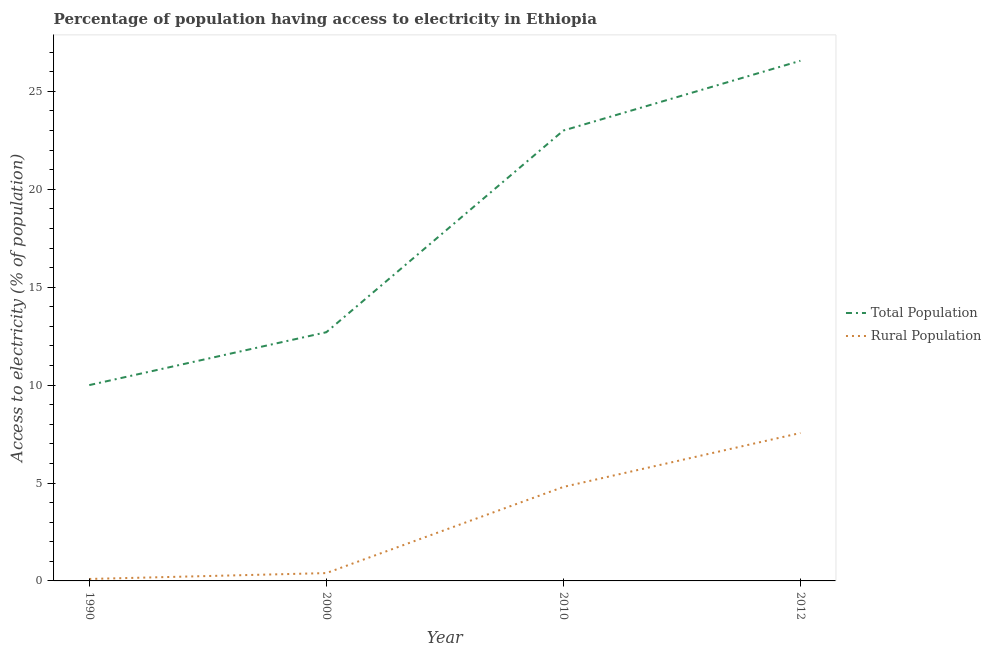Is the number of lines equal to the number of legend labels?
Ensure brevity in your answer.  Yes. Across all years, what is the maximum percentage of rural population having access to electricity?
Offer a very short reply. 7.55. What is the total percentage of population having access to electricity in the graph?
Your answer should be compact. 72.26. What is the difference between the percentage of rural population having access to electricity in 1990 and that in 2000?
Your response must be concise. -0.3. What is the difference between the percentage of population having access to electricity in 1990 and the percentage of rural population having access to electricity in 2012?
Keep it short and to the point. 2.45. What is the average percentage of rural population having access to electricity per year?
Your answer should be very brief. 3.21. In the year 2000, what is the difference between the percentage of rural population having access to electricity and percentage of population having access to electricity?
Your response must be concise. -12.3. What is the ratio of the percentage of population having access to electricity in 2000 to that in 2012?
Your answer should be compact. 0.48. What is the difference between the highest and the second highest percentage of population having access to electricity?
Ensure brevity in your answer.  3.56. What is the difference between the highest and the lowest percentage of population having access to electricity?
Keep it short and to the point. 16.56. Is the percentage of rural population having access to electricity strictly less than the percentage of population having access to electricity over the years?
Keep it short and to the point. Yes. How many lines are there?
Ensure brevity in your answer.  2. What is the difference between two consecutive major ticks on the Y-axis?
Your answer should be very brief. 5. Are the values on the major ticks of Y-axis written in scientific E-notation?
Make the answer very short. No. Does the graph contain grids?
Your answer should be very brief. No. What is the title of the graph?
Your answer should be compact. Percentage of population having access to electricity in Ethiopia. What is the label or title of the Y-axis?
Provide a short and direct response. Access to electricity (% of population). What is the Access to electricity (% of population) in Rural Population in 2000?
Ensure brevity in your answer.  0.4. What is the Access to electricity (% of population) of Total Population in 2010?
Provide a succinct answer. 23. What is the Access to electricity (% of population) of Total Population in 2012?
Your answer should be compact. 26.56. What is the Access to electricity (% of population) of Rural Population in 2012?
Give a very brief answer. 7.55. Across all years, what is the maximum Access to electricity (% of population) of Total Population?
Your answer should be very brief. 26.56. Across all years, what is the maximum Access to electricity (% of population) of Rural Population?
Your answer should be compact. 7.55. What is the total Access to electricity (% of population) in Total Population in the graph?
Make the answer very short. 72.26. What is the total Access to electricity (% of population) of Rural Population in the graph?
Provide a short and direct response. 12.85. What is the difference between the Access to electricity (% of population) in Total Population in 1990 and that in 2000?
Keep it short and to the point. -2.7. What is the difference between the Access to electricity (% of population) in Rural Population in 1990 and that in 2000?
Your answer should be very brief. -0.3. What is the difference between the Access to electricity (% of population) in Total Population in 1990 and that in 2010?
Keep it short and to the point. -13. What is the difference between the Access to electricity (% of population) in Total Population in 1990 and that in 2012?
Offer a terse response. -16.56. What is the difference between the Access to electricity (% of population) in Rural Population in 1990 and that in 2012?
Offer a terse response. -7.45. What is the difference between the Access to electricity (% of population) in Total Population in 2000 and that in 2010?
Provide a succinct answer. -10.3. What is the difference between the Access to electricity (% of population) in Rural Population in 2000 and that in 2010?
Provide a succinct answer. -4.4. What is the difference between the Access to electricity (% of population) of Total Population in 2000 and that in 2012?
Give a very brief answer. -13.86. What is the difference between the Access to electricity (% of population) of Rural Population in 2000 and that in 2012?
Give a very brief answer. -7.15. What is the difference between the Access to electricity (% of population) of Total Population in 2010 and that in 2012?
Keep it short and to the point. -3.56. What is the difference between the Access to electricity (% of population) in Rural Population in 2010 and that in 2012?
Offer a very short reply. -2.75. What is the difference between the Access to electricity (% of population) of Total Population in 1990 and the Access to electricity (% of population) of Rural Population in 2010?
Provide a short and direct response. 5.2. What is the difference between the Access to electricity (% of population) of Total Population in 1990 and the Access to electricity (% of population) of Rural Population in 2012?
Your answer should be compact. 2.45. What is the difference between the Access to electricity (% of population) in Total Population in 2000 and the Access to electricity (% of population) in Rural Population in 2012?
Offer a very short reply. 5.15. What is the difference between the Access to electricity (% of population) in Total Population in 2010 and the Access to electricity (% of population) in Rural Population in 2012?
Make the answer very short. 15.45. What is the average Access to electricity (% of population) of Total Population per year?
Your answer should be compact. 18.07. What is the average Access to electricity (% of population) of Rural Population per year?
Your response must be concise. 3.21. In the year 1990, what is the difference between the Access to electricity (% of population) in Total Population and Access to electricity (% of population) in Rural Population?
Offer a terse response. 9.9. In the year 2012, what is the difference between the Access to electricity (% of population) of Total Population and Access to electricity (% of population) of Rural Population?
Ensure brevity in your answer.  19.01. What is the ratio of the Access to electricity (% of population) in Total Population in 1990 to that in 2000?
Give a very brief answer. 0.79. What is the ratio of the Access to electricity (% of population) in Total Population in 1990 to that in 2010?
Offer a very short reply. 0.43. What is the ratio of the Access to electricity (% of population) of Rural Population in 1990 to that in 2010?
Your answer should be compact. 0.02. What is the ratio of the Access to electricity (% of population) of Total Population in 1990 to that in 2012?
Provide a succinct answer. 0.38. What is the ratio of the Access to electricity (% of population) in Rural Population in 1990 to that in 2012?
Ensure brevity in your answer.  0.01. What is the ratio of the Access to electricity (% of population) in Total Population in 2000 to that in 2010?
Give a very brief answer. 0.55. What is the ratio of the Access to electricity (% of population) of Rural Population in 2000 to that in 2010?
Ensure brevity in your answer.  0.08. What is the ratio of the Access to electricity (% of population) in Total Population in 2000 to that in 2012?
Your answer should be very brief. 0.48. What is the ratio of the Access to electricity (% of population) of Rural Population in 2000 to that in 2012?
Your answer should be very brief. 0.05. What is the ratio of the Access to electricity (% of population) in Total Population in 2010 to that in 2012?
Provide a succinct answer. 0.87. What is the ratio of the Access to electricity (% of population) in Rural Population in 2010 to that in 2012?
Ensure brevity in your answer.  0.64. What is the difference between the highest and the second highest Access to electricity (% of population) of Total Population?
Keep it short and to the point. 3.56. What is the difference between the highest and the second highest Access to electricity (% of population) in Rural Population?
Provide a succinct answer. 2.75. What is the difference between the highest and the lowest Access to electricity (% of population) in Total Population?
Your answer should be very brief. 16.56. What is the difference between the highest and the lowest Access to electricity (% of population) in Rural Population?
Provide a short and direct response. 7.45. 